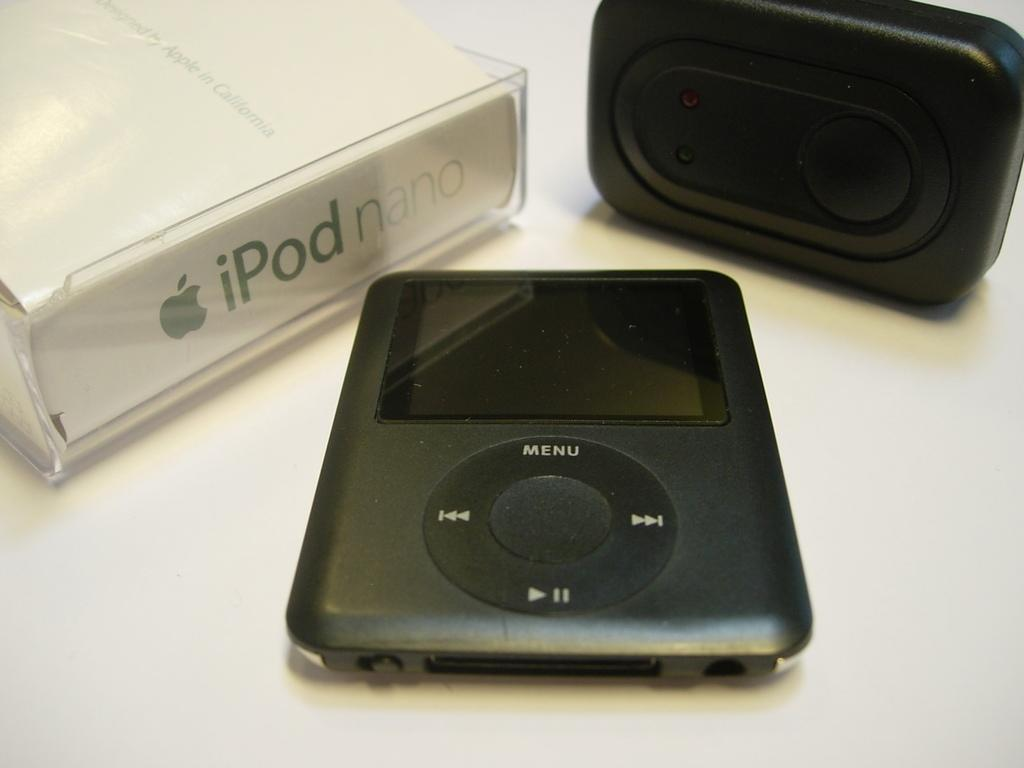How many devices can be seen in the image? There are two devices in the image. What else is present in the image besides the devices? There is a box in the image. Where are the devices and the box located? The devices and the box are placed on a platform. What direction is the zebra facing in the image? There is no zebra present in the image. What action are the devices performing in the image? The provided facts do not mention any actions being performed by the devices, so we cannot answer this question definitively. 